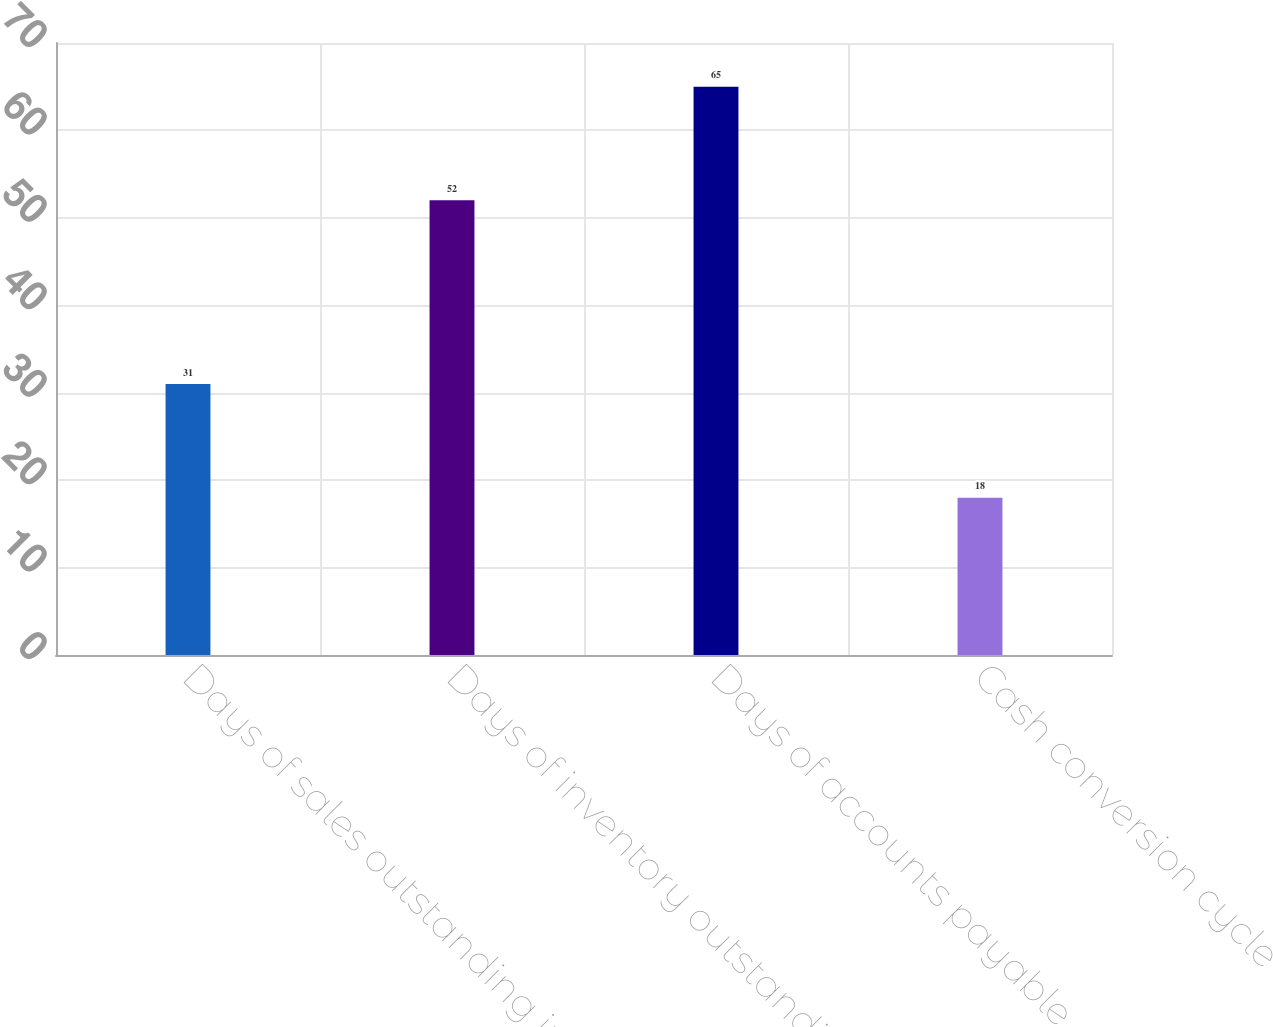<chart> <loc_0><loc_0><loc_500><loc_500><bar_chart><fcel>Days of sales outstanding in<fcel>Days of inventory outstanding<fcel>Days of accounts payable<fcel>Cash conversion cycle<nl><fcel>31<fcel>52<fcel>65<fcel>18<nl></chart> 